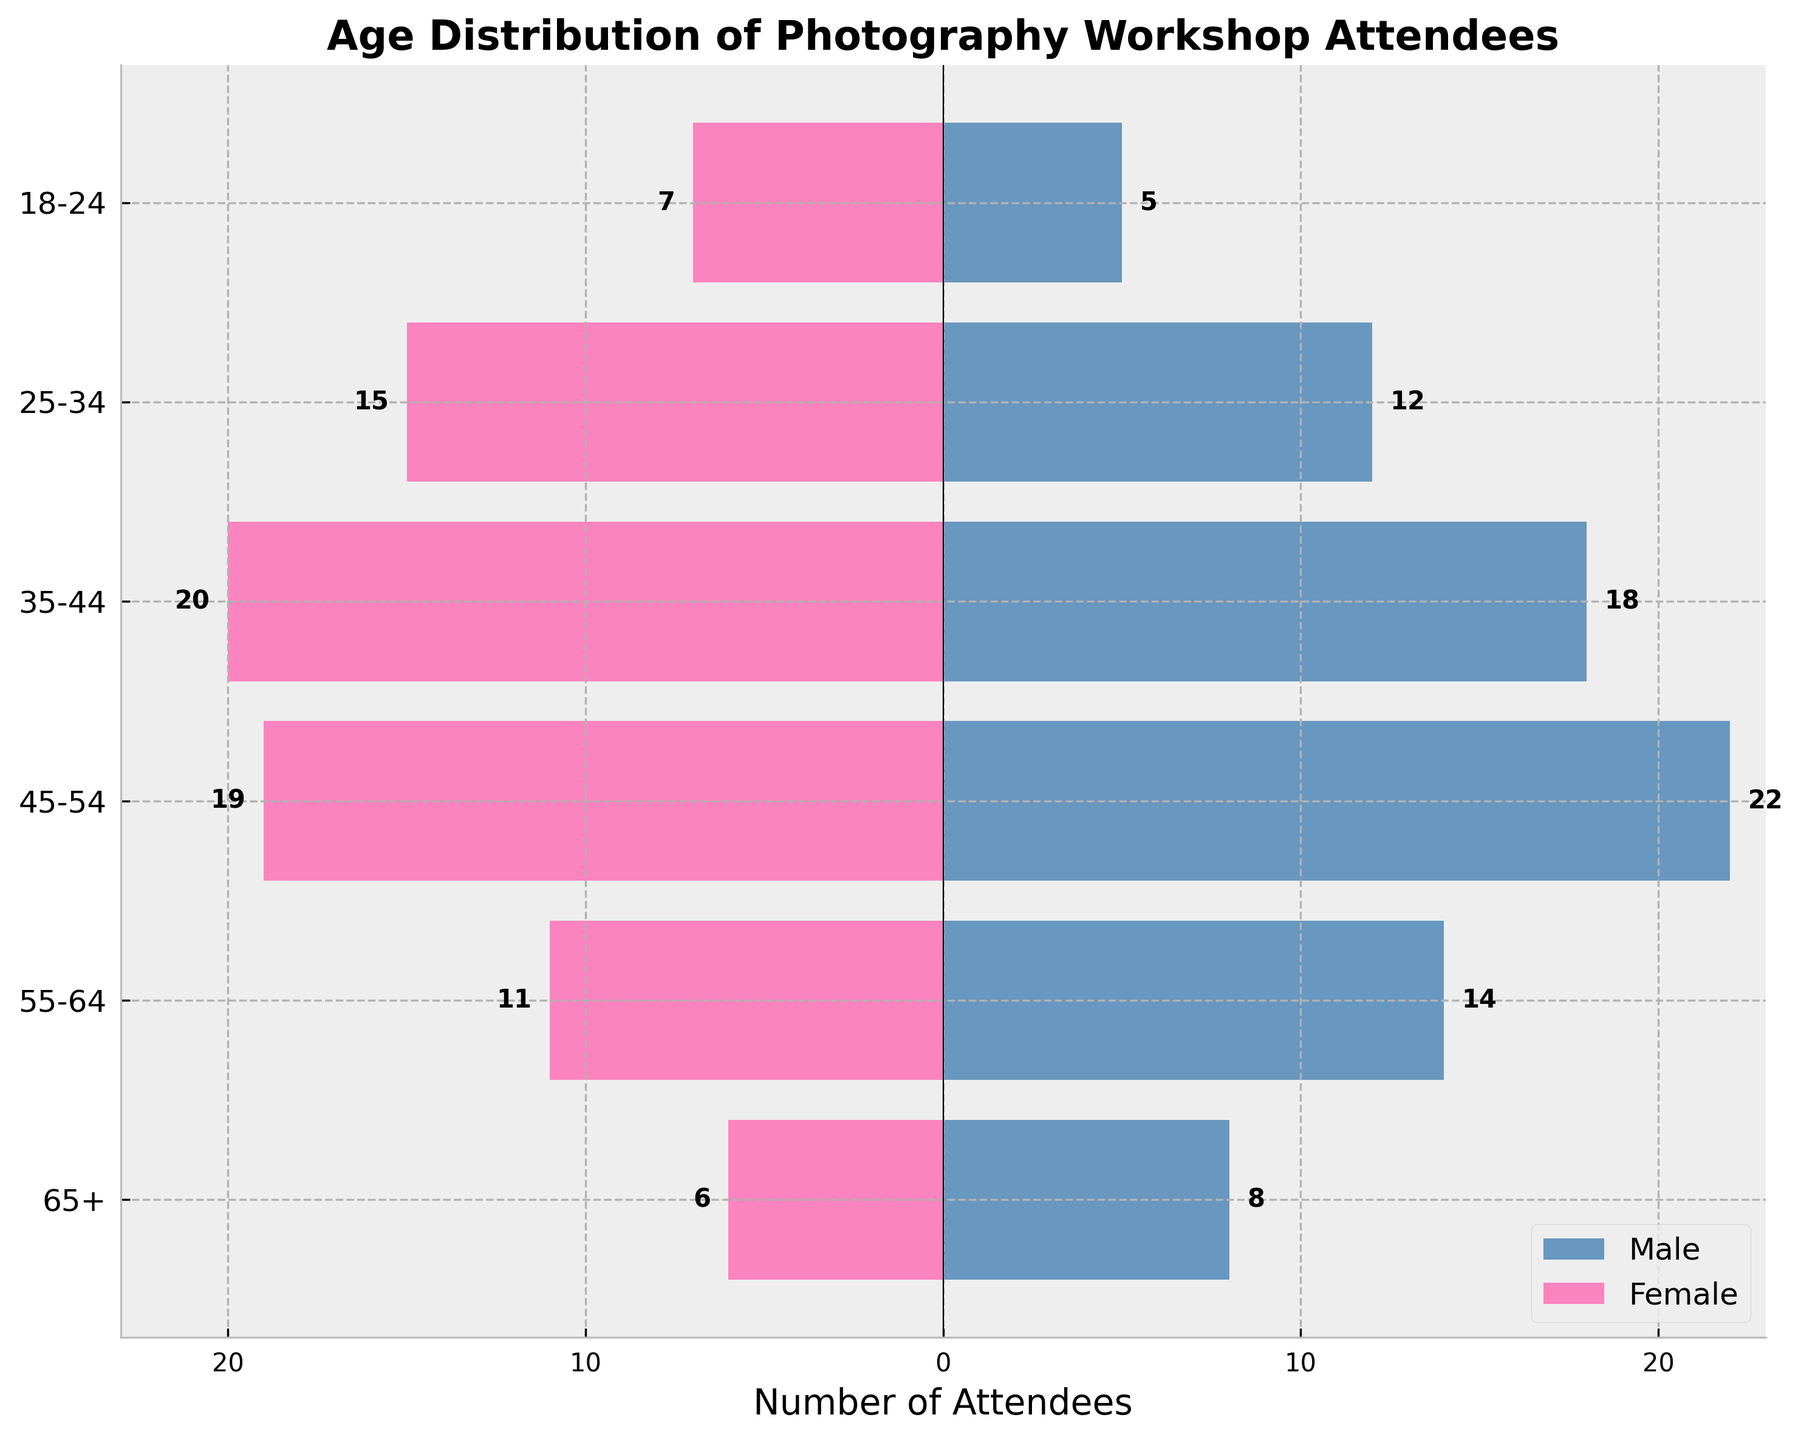What is the title of the figure? The title of the figure is generally located at the top and is usually the largest text on the plot. It provides an overview of what the plot represents.
Answer: Age Distribution of Photography Workshop Attendees How many age groups are there in the figure? The y-axis labels each age group, with one tick mark per group, indicating the discrete categories plotted.
Answer: 6 Which age group has the highest number of male attendees? To determine this, locate the bar that extends furthest to the right on the positive side (male).
Answer: 45-54 What is the total number of female attendees in the 35-44 age group? Observe the length of the bar extending to the left for the 35-44 age group and read the numerical label.
Answer: 20 How does the number of male attendees in the 55-64 age group compare to the number of female attendees in the same group? Compare the lengths of the bars for males and females in the 55-64 age group. The numerical values next to the bars can be used to confirm the comparison.
Answer: There are 3 more males than females (14 males vs. 11 females) Which age group has nearly an equal number of male and female attendees? Compare the lengths of male and female bars for each age group to identify the one with the smallest difference between them.
Answer: 18-24 and 25-34 (both have a small difference) What is the combined total number of attendees in the 65+ age group? Add the number of male and female attendees in the 65+ age group by combining the lengths of both bars for that group.
Answer: 14 (8 males + 6 females) Does any age group have more female attendees than male attendees? Look for age groups where the bar extending to the left (female) is longer than the bar extending to the right (male).
Answer: Yes, the 18-24 age group What is the average number of attendees for the 25-34 and 45-54 age groups? Calculate the total number of attendees in these two age groups by adding the populations of males and females, then divide the sum by two to find the average.
Answer: (12 males + 15 females + 22 males + 19 females) / 2 = 34.5 How does the distribution of male and female attendees change with age according to the figure? Observe the patterns in bar lengths for males and females across all age groups to understand general trends, such as male dominance in certain groups and distributions in others.
Answer: Males generally increase and then gradually decrease, whereas females exceed males in the youngest group and then peak at 35-44 before decreasing 